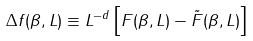<formula> <loc_0><loc_0><loc_500><loc_500>\Delta f ( \beta , L ) \equiv L ^ { - d } \left [ F ( \beta , L ) - \tilde { F } ( \beta , L ) \right ]</formula> 